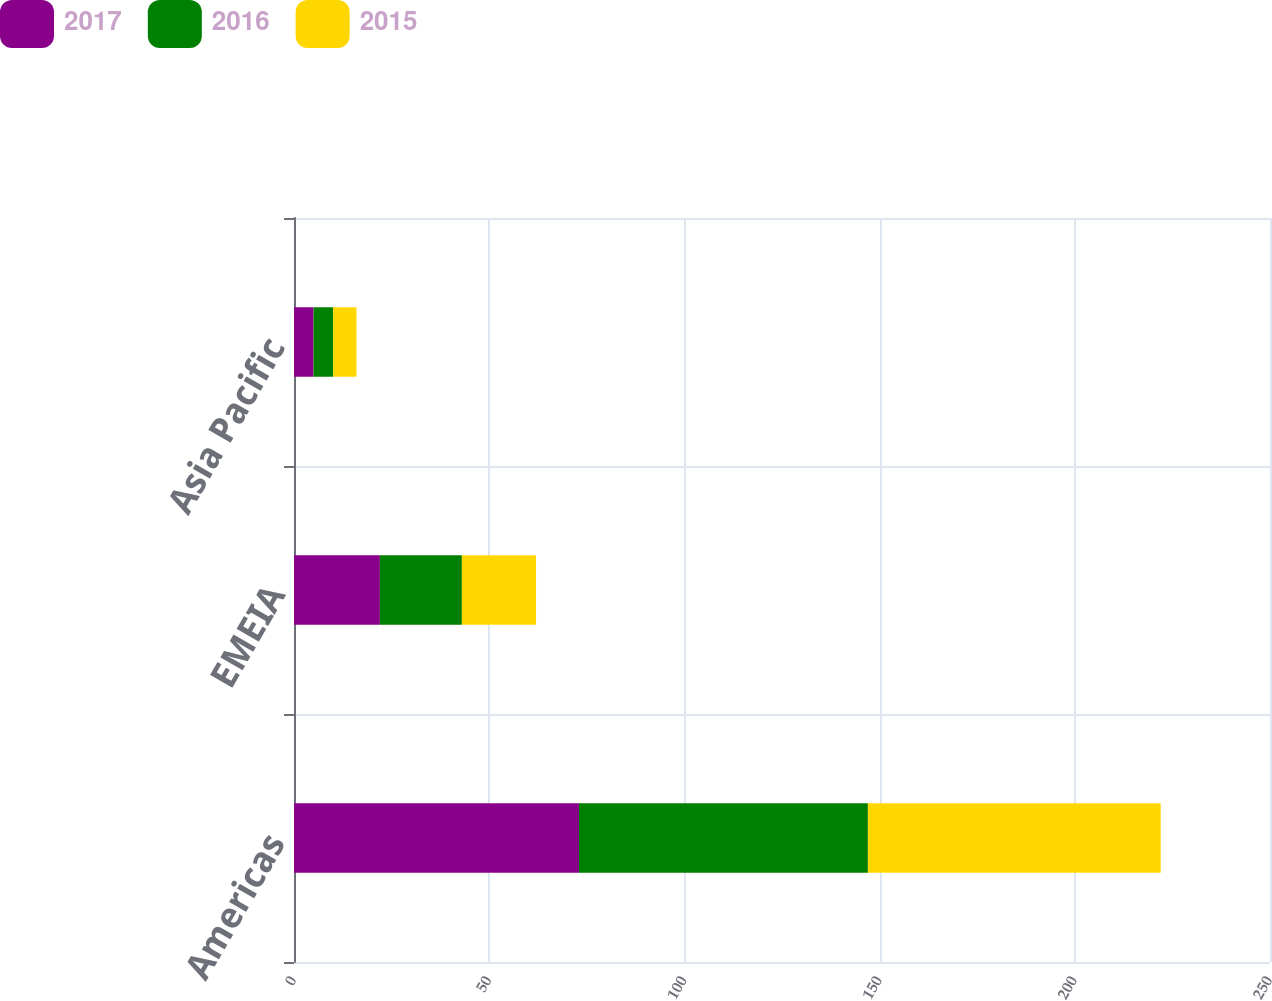Convert chart. <chart><loc_0><loc_0><loc_500><loc_500><stacked_bar_chart><ecel><fcel>Americas<fcel>EMEIA<fcel>Asia Pacific<nl><fcel>2017<fcel>73<fcel>22<fcel>5<nl><fcel>2016<fcel>74<fcel>21<fcel>5<nl><fcel>2015<fcel>75<fcel>19<fcel>6<nl></chart> 